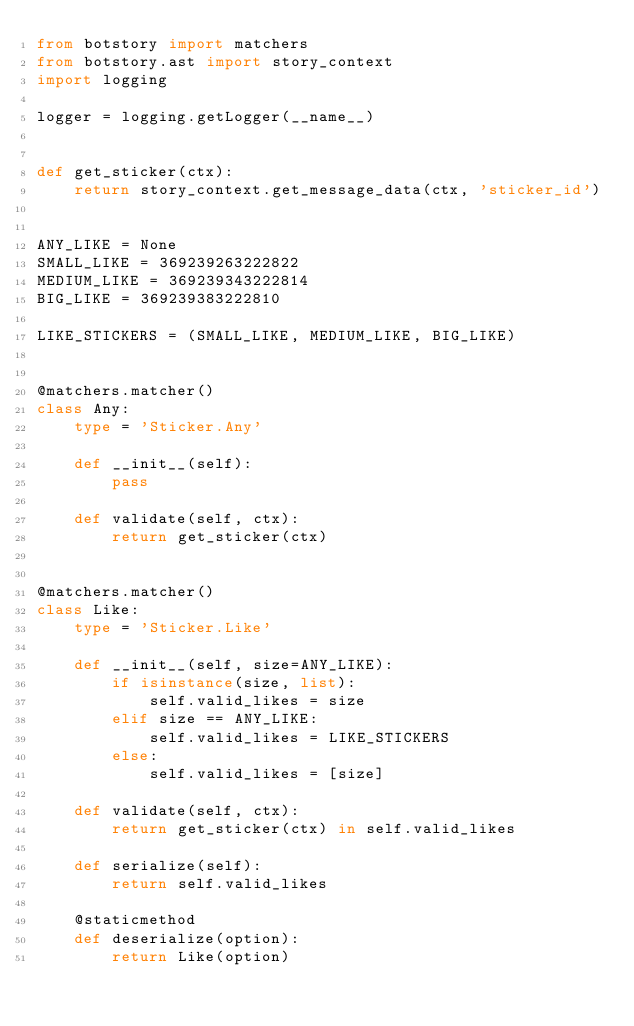<code> <loc_0><loc_0><loc_500><loc_500><_Python_>from botstory import matchers
from botstory.ast import story_context
import logging

logger = logging.getLogger(__name__)


def get_sticker(ctx):
    return story_context.get_message_data(ctx, 'sticker_id')


ANY_LIKE = None
SMALL_LIKE = 369239263222822
MEDIUM_LIKE = 369239343222814
BIG_LIKE = 369239383222810

LIKE_STICKERS = (SMALL_LIKE, MEDIUM_LIKE, BIG_LIKE)


@matchers.matcher()
class Any:
    type = 'Sticker.Any'

    def __init__(self):
        pass

    def validate(self, ctx):
        return get_sticker(ctx)


@matchers.matcher()
class Like:
    type = 'Sticker.Like'

    def __init__(self, size=ANY_LIKE):
        if isinstance(size, list):
            self.valid_likes = size
        elif size == ANY_LIKE:
            self.valid_likes = LIKE_STICKERS
        else:
            self.valid_likes = [size]

    def validate(self, ctx):
        return get_sticker(ctx) in self.valid_likes

    def serialize(self):
        return self.valid_likes

    @staticmethod
    def deserialize(option):
        return Like(option)
</code> 